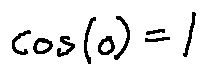<formula> <loc_0><loc_0><loc_500><loc_500>\cos ( 0 ) = 1</formula> 